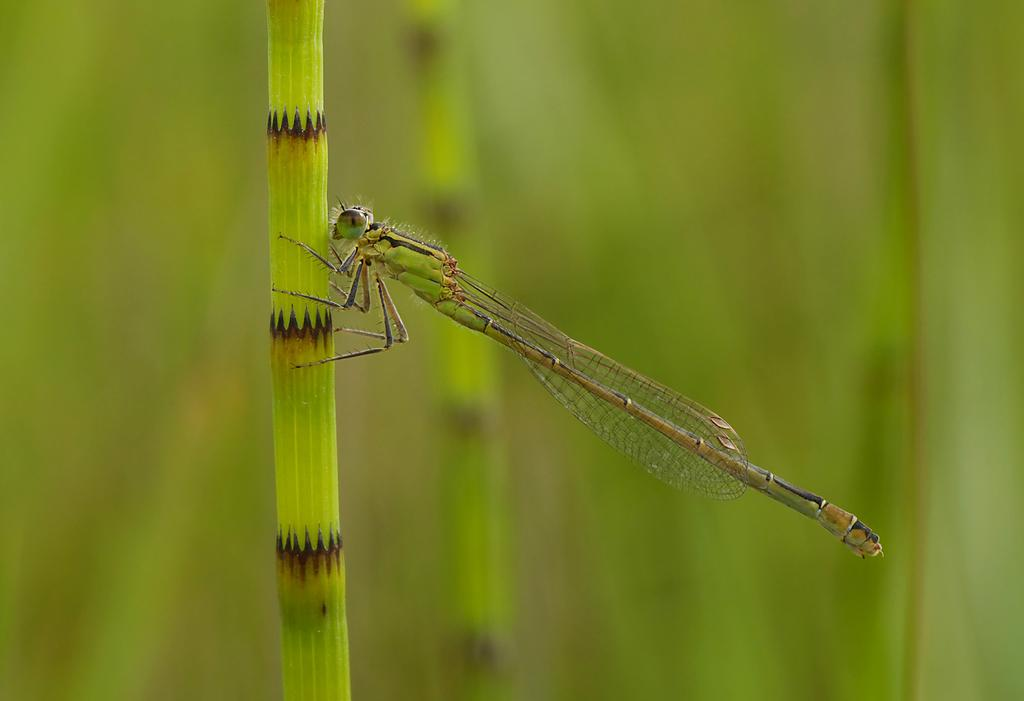What type of creature can be seen in the image? There is an insect in the image. Where is the insect located? The insect is on a plant. Can you describe the background of the image? The background of the image is blurred. What type of dinner is being served on the insect's wrist in the image? There is no dinner or wrist present in the image; it features an insect on a plant with a blurred background. 